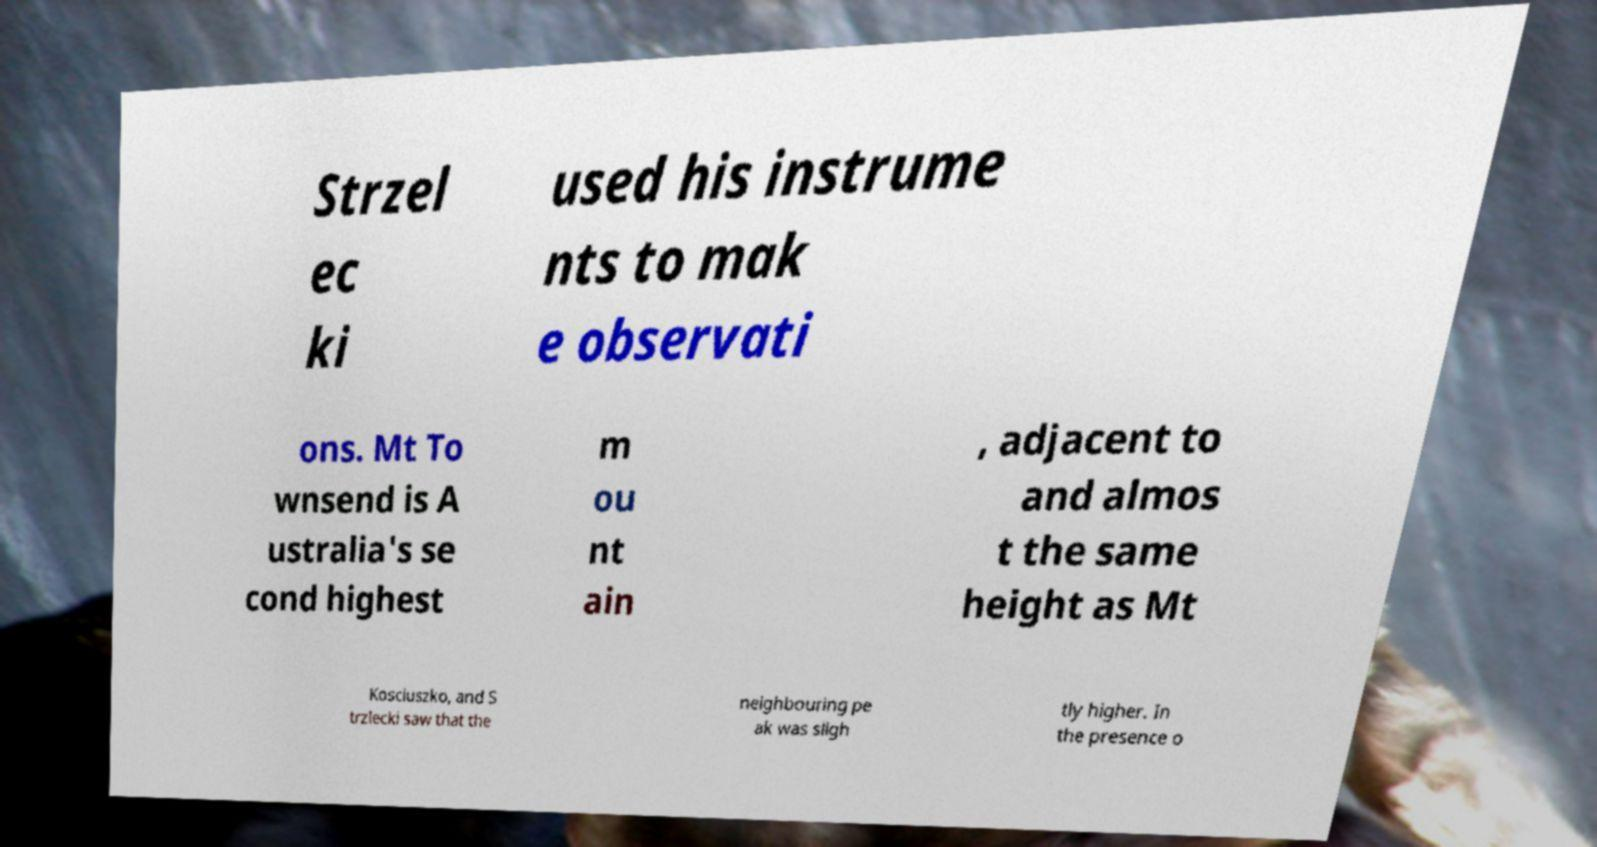Could you extract and type out the text from this image? Strzel ec ki used his instrume nts to mak e observati ons. Mt To wnsend is A ustralia's se cond highest m ou nt ain , adjacent to and almos t the same height as Mt Kosciuszko, and S trzlecki saw that the neighbouring pe ak was sligh tly higher. In the presence o 